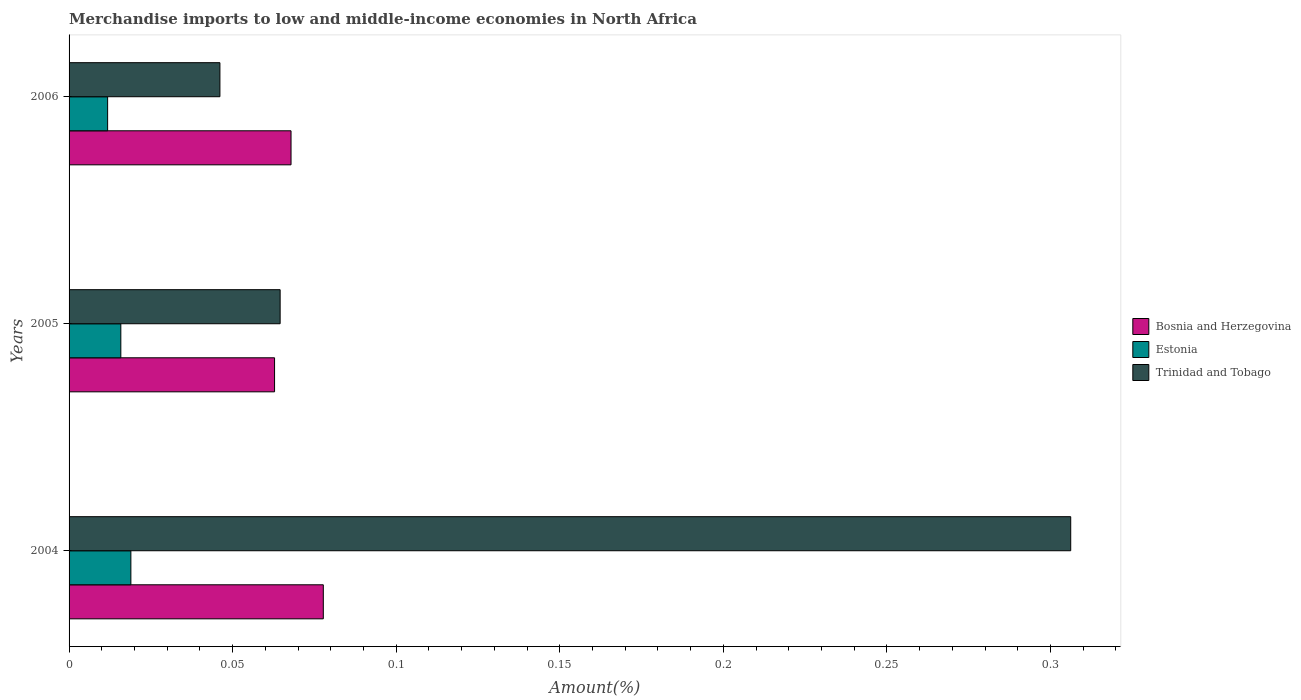How many different coloured bars are there?
Your response must be concise. 3. How many groups of bars are there?
Make the answer very short. 3. Are the number of bars per tick equal to the number of legend labels?
Offer a terse response. Yes. How many bars are there on the 1st tick from the bottom?
Your response must be concise. 3. What is the label of the 1st group of bars from the top?
Your answer should be very brief. 2006. What is the percentage of amount earned from merchandise imports in Estonia in 2004?
Ensure brevity in your answer.  0.02. Across all years, what is the maximum percentage of amount earned from merchandise imports in Bosnia and Herzegovina?
Keep it short and to the point. 0.08. Across all years, what is the minimum percentage of amount earned from merchandise imports in Bosnia and Herzegovina?
Keep it short and to the point. 0.06. In which year was the percentage of amount earned from merchandise imports in Estonia maximum?
Keep it short and to the point. 2004. What is the total percentage of amount earned from merchandise imports in Bosnia and Herzegovina in the graph?
Make the answer very short. 0.21. What is the difference between the percentage of amount earned from merchandise imports in Bosnia and Herzegovina in 2004 and that in 2005?
Your answer should be very brief. 0.01. What is the difference between the percentage of amount earned from merchandise imports in Bosnia and Herzegovina in 2006 and the percentage of amount earned from merchandise imports in Trinidad and Tobago in 2005?
Your answer should be very brief. 0. What is the average percentage of amount earned from merchandise imports in Estonia per year?
Provide a succinct answer. 0.02. In the year 2005, what is the difference between the percentage of amount earned from merchandise imports in Bosnia and Herzegovina and percentage of amount earned from merchandise imports in Trinidad and Tobago?
Ensure brevity in your answer.  -0. What is the ratio of the percentage of amount earned from merchandise imports in Estonia in 2004 to that in 2005?
Provide a succinct answer. 1.19. Is the difference between the percentage of amount earned from merchandise imports in Bosnia and Herzegovina in 2005 and 2006 greater than the difference between the percentage of amount earned from merchandise imports in Trinidad and Tobago in 2005 and 2006?
Give a very brief answer. No. What is the difference between the highest and the second highest percentage of amount earned from merchandise imports in Bosnia and Herzegovina?
Your answer should be very brief. 0.01. What is the difference between the highest and the lowest percentage of amount earned from merchandise imports in Bosnia and Herzegovina?
Your answer should be very brief. 0.01. Is the sum of the percentage of amount earned from merchandise imports in Bosnia and Herzegovina in 2005 and 2006 greater than the maximum percentage of amount earned from merchandise imports in Estonia across all years?
Provide a succinct answer. Yes. What does the 3rd bar from the top in 2006 represents?
Ensure brevity in your answer.  Bosnia and Herzegovina. What does the 1st bar from the bottom in 2005 represents?
Your answer should be very brief. Bosnia and Herzegovina. Is it the case that in every year, the sum of the percentage of amount earned from merchandise imports in Trinidad and Tobago and percentage of amount earned from merchandise imports in Estonia is greater than the percentage of amount earned from merchandise imports in Bosnia and Herzegovina?
Provide a succinct answer. No. Are all the bars in the graph horizontal?
Offer a very short reply. Yes. What is the difference between two consecutive major ticks on the X-axis?
Your response must be concise. 0.05. Are the values on the major ticks of X-axis written in scientific E-notation?
Your answer should be very brief. No. Where does the legend appear in the graph?
Keep it short and to the point. Center right. How many legend labels are there?
Provide a succinct answer. 3. What is the title of the graph?
Offer a very short reply. Merchandise imports to low and middle-income economies in North Africa. Does "Greenland" appear as one of the legend labels in the graph?
Your response must be concise. No. What is the label or title of the X-axis?
Ensure brevity in your answer.  Amount(%). What is the label or title of the Y-axis?
Offer a terse response. Years. What is the Amount(%) of Bosnia and Herzegovina in 2004?
Keep it short and to the point. 0.08. What is the Amount(%) of Estonia in 2004?
Keep it short and to the point. 0.02. What is the Amount(%) in Trinidad and Tobago in 2004?
Give a very brief answer. 0.31. What is the Amount(%) of Bosnia and Herzegovina in 2005?
Your answer should be compact. 0.06. What is the Amount(%) of Estonia in 2005?
Keep it short and to the point. 0.02. What is the Amount(%) in Trinidad and Tobago in 2005?
Make the answer very short. 0.06. What is the Amount(%) in Bosnia and Herzegovina in 2006?
Your response must be concise. 0.07. What is the Amount(%) in Estonia in 2006?
Give a very brief answer. 0.01. What is the Amount(%) of Trinidad and Tobago in 2006?
Offer a very short reply. 0.05. Across all years, what is the maximum Amount(%) of Bosnia and Herzegovina?
Offer a terse response. 0.08. Across all years, what is the maximum Amount(%) of Estonia?
Make the answer very short. 0.02. Across all years, what is the maximum Amount(%) of Trinidad and Tobago?
Offer a terse response. 0.31. Across all years, what is the minimum Amount(%) of Bosnia and Herzegovina?
Your answer should be very brief. 0.06. Across all years, what is the minimum Amount(%) of Estonia?
Your response must be concise. 0.01. Across all years, what is the minimum Amount(%) in Trinidad and Tobago?
Your answer should be compact. 0.05. What is the total Amount(%) of Bosnia and Herzegovina in the graph?
Give a very brief answer. 0.21. What is the total Amount(%) in Estonia in the graph?
Keep it short and to the point. 0.05. What is the total Amount(%) of Trinidad and Tobago in the graph?
Your answer should be compact. 0.42. What is the difference between the Amount(%) in Bosnia and Herzegovina in 2004 and that in 2005?
Provide a succinct answer. 0.01. What is the difference between the Amount(%) in Estonia in 2004 and that in 2005?
Provide a short and direct response. 0. What is the difference between the Amount(%) in Trinidad and Tobago in 2004 and that in 2005?
Keep it short and to the point. 0.24. What is the difference between the Amount(%) of Bosnia and Herzegovina in 2004 and that in 2006?
Make the answer very short. 0.01. What is the difference between the Amount(%) of Estonia in 2004 and that in 2006?
Give a very brief answer. 0.01. What is the difference between the Amount(%) in Trinidad and Tobago in 2004 and that in 2006?
Your response must be concise. 0.26. What is the difference between the Amount(%) of Bosnia and Herzegovina in 2005 and that in 2006?
Your answer should be compact. -0.01. What is the difference between the Amount(%) of Estonia in 2005 and that in 2006?
Offer a very short reply. 0. What is the difference between the Amount(%) in Trinidad and Tobago in 2005 and that in 2006?
Provide a short and direct response. 0.02. What is the difference between the Amount(%) of Bosnia and Herzegovina in 2004 and the Amount(%) of Estonia in 2005?
Give a very brief answer. 0.06. What is the difference between the Amount(%) in Bosnia and Herzegovina in 2004 and the Amount(%) in Trinidad and Tobago in 2005?
Your answer should be very brief. 0.01. What is the difference between the Amount(%) of Estonia in 2004 and the Amount(%) of Trinidad and Tobago in 2005?
Your response must be concise. -0.05. What is the difference between the Amount(%) of Bosnia and Herzegovina in 2004 and the Amount(%) of Estonia in 2006?
Ensure brevity in your answer.  0.07. What is the difference between the Amount(%) of Bosnia and Herzegovina in 2004 and the Amount(%) of Trinidad and Tobago in 2006?
Your answer should be very brief. 0.03. What is the difference between the Amount(%) in Estonia in 2004 and the Amount(%) in Trinidad and Tobago in 2006?
Make the answer very short. -0.03. What is the difference between the Amount(%) in Bosnia and Herzegovina in 2005 and the Amount(%) in Estonia in 2006?
Your answer should be compact. 0.05. What is the difference between the Amount(%) in Bosnia and Herzegovina in 2005 and the Amount(%) in Trinidad and Tobago in 2006?
Offer a very short reply. 0.02. What is the difference between the Amount(%) in Estonia in 2005 and the Amount(%) in Trinidad and Tobago in 2006?
Provide a short and direct response. -0.03. What is the average Amount(%) in Bosnia and Herzegovina per year?
Ensure brevity in your answer.  0.07. What is the average Amount(%) in Estonia per year?
Keep it short and to the point. 0.02. What is the average Amount(%) of Trinidad and Tobago per year?
Provide a short and direct response. 0.14. In the year 2004, what is the difference between the Amount(%) of Bosnia and Herzegovina and Amount(%) of Estonia?
Your response must be concise. 0.06. In the year 2004, what is the difference between the Amount(%) of Bosnia and Herzegovina and Amount(%) of Trinidad and Tobago?
Your answer should be very brief. -0.23. In the year 2004, what is the difference between the Amount(%) in Estonia and Amount(%) in Trinidad and Tobago?
Give a very brief answer. -0.29. In the year 2005, what is the difference between the Amount(%) of Bosnia and Herzegovina and Amount(%) of Estonia?
Provide a succinct answer. 0.05. In the year 2005, what is the difference between the Amount(%) in Bosnia and Herzegovina and Amount(%) in Trinidad and Tobago?
Your answer should be very brief. -0. In the year 2005, what is the difference between the Amount(%) in Estonia and Amount(%) in Trinidad and Tobago?
Provide a succinct answer. -0.05. In the year 2006, what is the difference between the Amount(%) in Bosnia and Herzegovina and Amount(%) in Estonia?
Offer a very short reply. 0.06. In the year 2006, what is the difference between the Amount(%) of Bosnia and Herzegovina and Amount(%) of Trinidad and Tobago?
Keep it short and to the point. 0.02. In the year 2006, what is the difference between the Amount(%) in Estonia and Amount(%) in Trinidad and Tobago?
Make the answer very short. -0.03. What is the ratio of the Amount(%) in Bosnia and Herzegovina in 2004 to that in 2005?
Your answer should be compact. 1.24. What is the ratio of the Amount(%) of Estonia in 2004 to that in 2005?
Give a very brief answer. 1.19. What is the ratio of the Amount(%) in Trinidad and Tobago in 2004 to that in 2005?
Your response must be concise. 4.75. What is the ratio of the Amount(%) of Bosnia and Herzegovina in 2004 to that in 2006?
Offer a terse response. 1.15. What is the ratio of the Amount(%) in Estonia in 2004 to that in 2006?
Offer a very short reply. 1.6. What is the ratio of the Amount(%) of Trinidad and Tobago in 2004 to that in 2006?
Make the answer very short. 6.64. What is the ratio of the Amount(%) in Bosnia and Herzegovina in 2005 to that in 2006?
Your answer should be very brief. 0.93. What is the ratio of the Amount(%) of Estonia in 2005 to that in 2006?
Make the answer very short. 1.34. What is the ratio of the Amount(%) in Trinidad and Tobago in 2005 to that in 2006?
Offer a very short reply. 1.4. What is the difference between the highest and the second highest Amount(%) of Bosnia and Herzegovina?
Give a very brief answer. 0.01. What is the difference between the highest and the second highest Amount(%) of Estonia?
Keep it short and to the point. 0. What is the difference between the highest and the second highest Amount(%) in Trinidad and Tobago?
Provide a succinct answer. 0.24. What is the difference between the highest and the lowest Amount(%) of Bosnia and Herzegovina?
Keep it short and to the point. 0.01. What is the difference between the highest and the lowest Amount(%) of Estonia?
Give a very brief answer. 0.01. What is the difference between the highest and the lowest Amount(%) in Trinidad and Tobago?
Offer a very short reply. 0.26. 